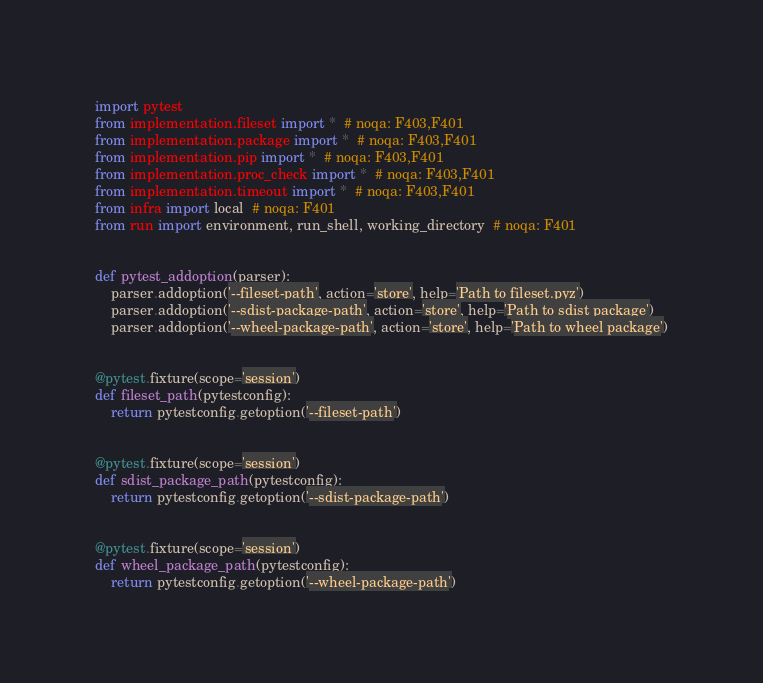<code> <loc_0><loc_0><loc_500><loc_500><_Python_>import pytest
from implementation.fileset import *  # noqa: F403,F401
from implementation.package import *  # noqa: F403,F401
from implementation.pip import *  # noqa: F403,F401
from implementation.proc_check import *  # noqa: F403,F401
from implementation.timeout import *  # noqa: F403,F401
from infra import local  # noqa: F401
from run import environment, run_shell, working_directory  # noqa: F401


def pytest_addoption(parser):
    parser.addoption('--fileset-path', action='store', help='Path to fileset.pyz')
    parser.addoption('--sdist-package-path', action='store', help='Path to sdist package')
    parser.addoption('--wheel-package-path', action='store', help='Path to wheel package')


@pytest.fixture(scope='session')
def fileset_path(pytestconfig):
    return pytestconfig.getoption('--fileset-path')


@pytest.fixture(scope='session')
def sdist_package_path(pytestconfig):
    return pytestconfig.getoption('--sdist-package-path')


@pytest.fixture(scope='session')
def wheel_package_path(pytestconfig):
    return pytestconfig.getoption('--wheel-package-path')
</code> 